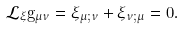Convert formula to latex. <formula><loc_0><loc_0><loc_500><loc_500>\mathcal { L } _ { \xi } g _ { \mu \nu } = \xi _ { \mu ; \nu } + \xi _ { \nu ; \mu } = 0 .</formula> 